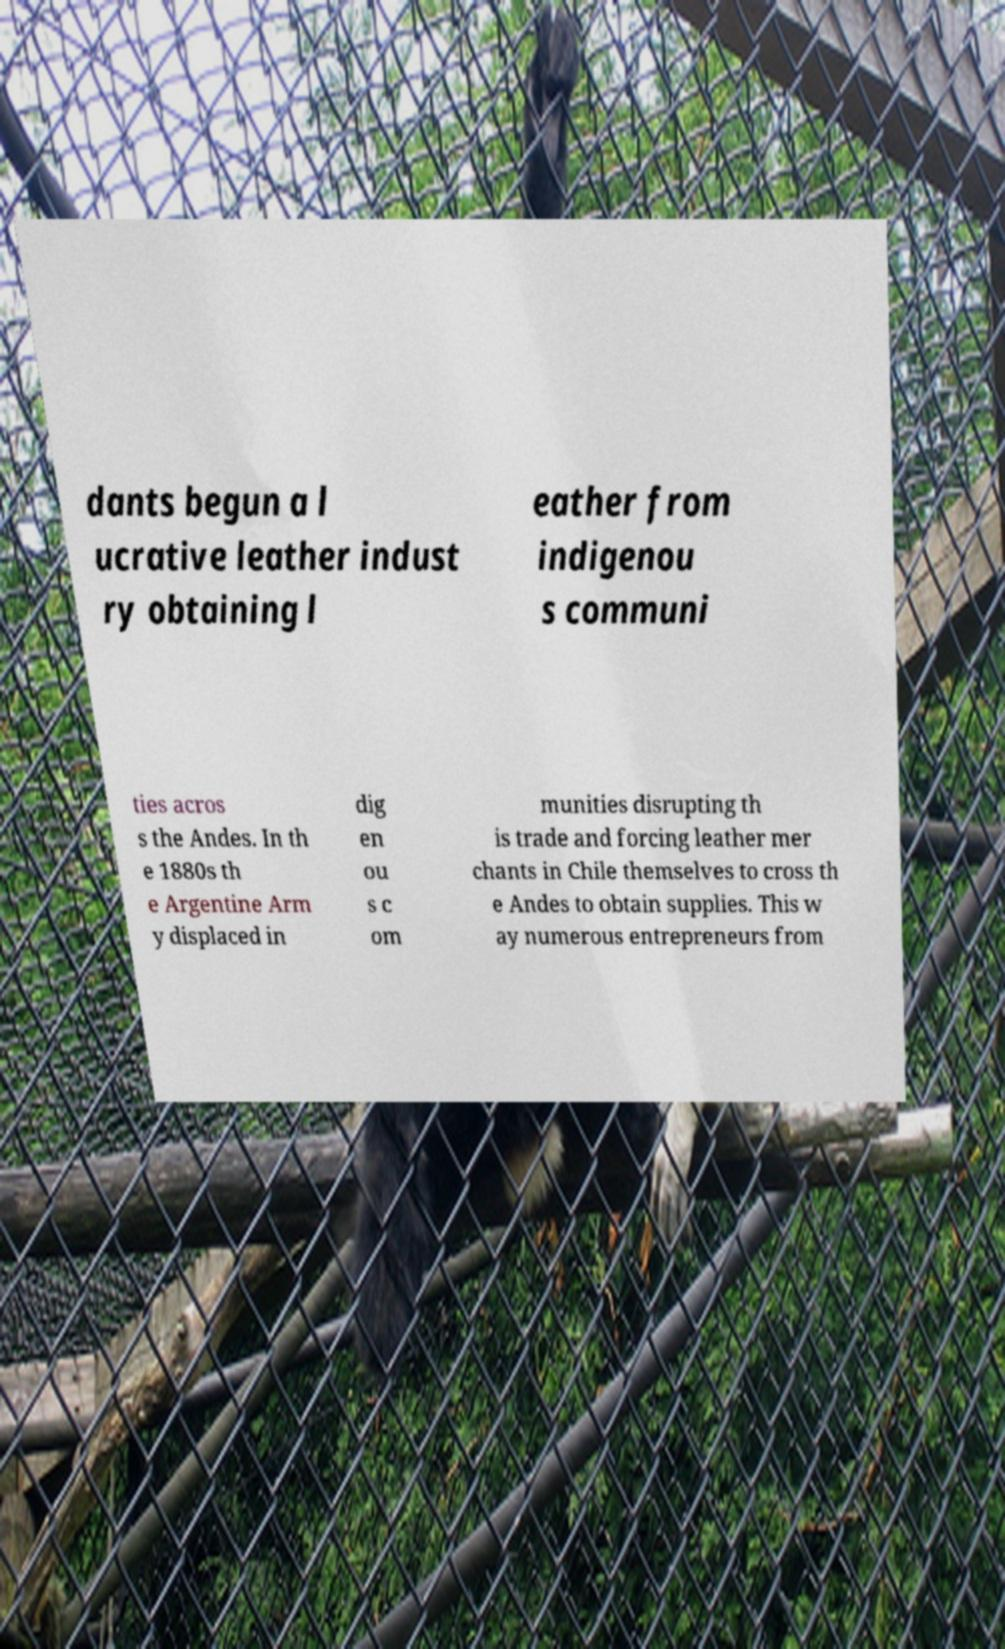Could you assist in decoding the text presented in this image and type it out clearly? dants begun a l ucrative leather indust ry obtaining l eather from indigenou s communi ties acros s the Andes. In th e 1880s th e Argentine Arm y displaced in dig en ou s c om munities disrupting th is trade and forcing leather mer chants in Chile themselves to cross th e Andes to obtain supplies. This w ay numerous entrepreneurs from 